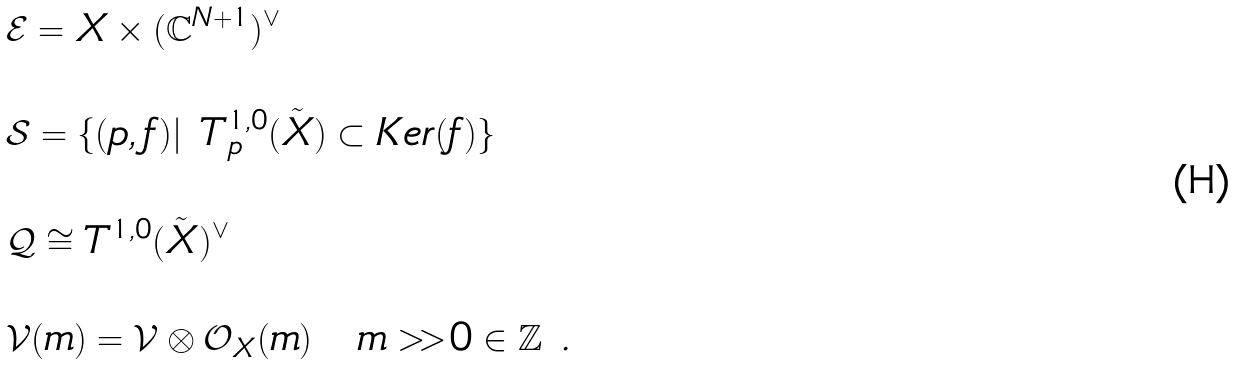<formula> <loc_0><loc_0><loc_500><loc_500>& \mathcal { E } = X \times ( \mathbb { C } ^ { N + 1 } ) ^ { \vee } \\ \ \\ & \mathcal { S } = \{ ( p , f ) | \ T ^ { 1 , 0 } _ { p } ( \tilde { X } ) \subset K e r ( f ) \} \\ \ \\ & \mathcal { Q } \cong T ^ { 1 , 0 } ( \tilde { X } ) ^ { \vee } \\ \ \\ & \mathcal { V } ( m ) = \mathcal { V } \otimes \mathcal { O } _ { X } ( m ) \quad m > > 0 \in \mathbb { Z } \ .</formula> 